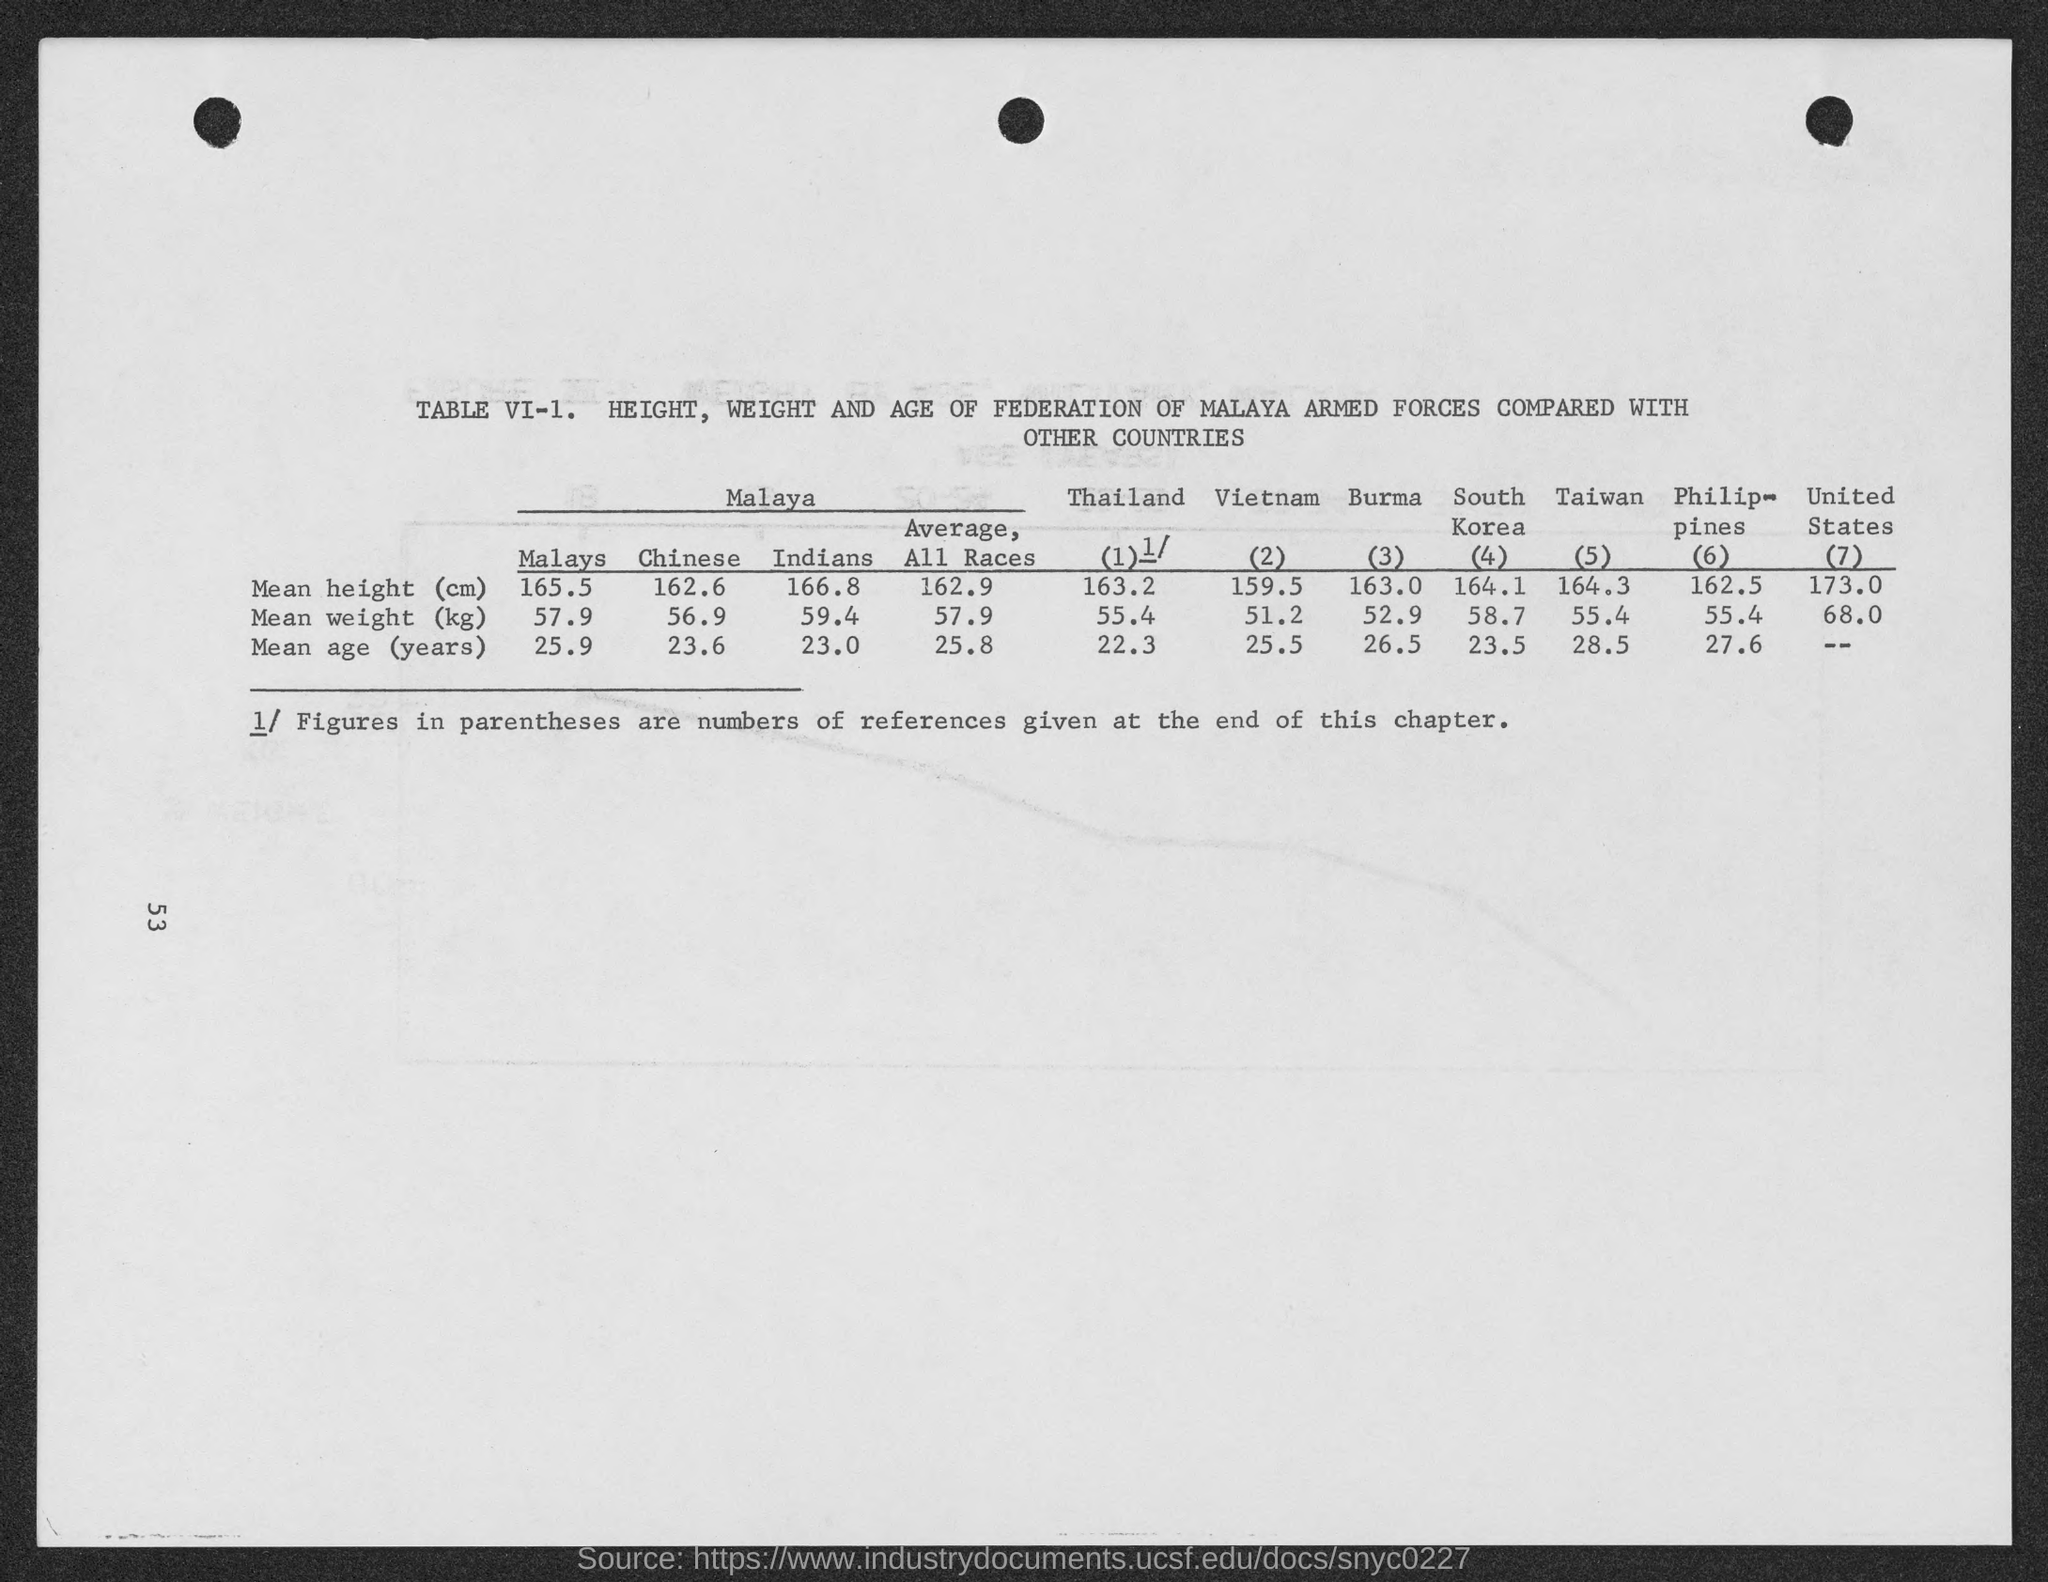Highlight a few significant elements in this photo. The mean height (in centimeters) in Taiwan is approximately 164.3. 高度的平均值是多少？（即162.6的约163公分）。 The mean height of people in Thailand is approximately 163.2 centimeters. The mean height (in centimeters) of Indians is 166.8. According to the data, the mean height (in centimeters) for all races is 162.9. 